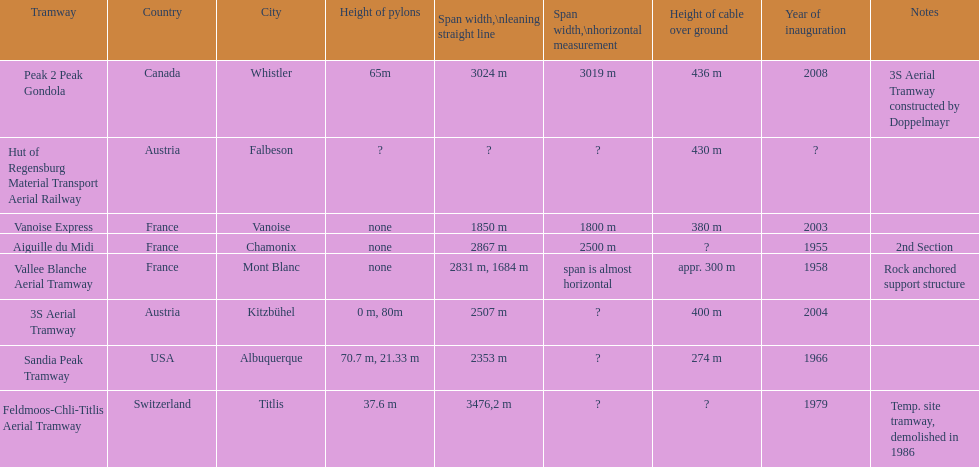What is the tramway that was developed directly before the 3s aerial tramway? Vanoise Express. 